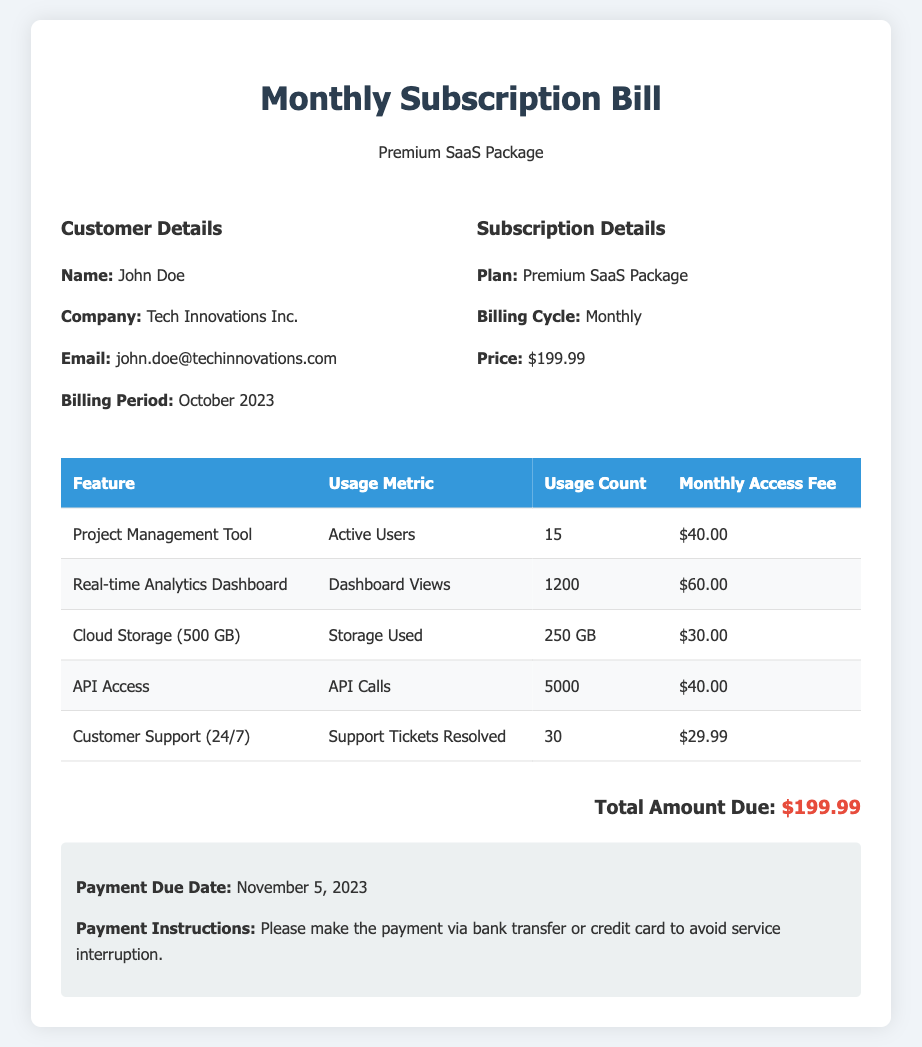What is the customer name? The document specifies the customer's name as John Doe.
Answer: John Doe What is the total amount due? The document indicates the total amount due is $199.99.
Answer: $199.99 How many active users are there for the Project Management Tool? The usage metric shows there are 15 active users for this feature.
Answer: 15 What is the billing period? The document states the billing period is for October 2023.
Answer: October 2023 What is the price of the Premium SaaS Package? The document lists the price of the Premium SaaS Package as $199.99.
Answer: $199.99 What feature has the highest usage count? The Real-time Analytics Dashboard has the highest usage count with 1200 dashboard views.
Answer: Real-time Analytics Dashboard When is the payment due date? According to the document, the payment due date is November 5, 2023.
Answer: November 5, 2023 How many support tickets were resolved? The document shows that 30 support tickets were resolved.
Answer: 30 What is the usage metric for Cloud Storage? The document states that the usage metric for Cloud Storage is Storage Used.
Answer: Storage Used What is the amount billed for API Access? According to the document, the amount billed for API Access is $40.00.
Answer: $40.00 